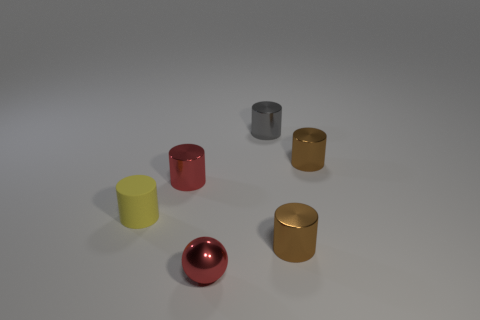Subtract all small yellow rubber cylinders. How many cylinders are left? 4 Subtract all gray cylinders. How many cylinders are left? 4 Subtract all cylinders. How many objects are left? 1 Subtract 1 spheres. How many spheres are left? 0 Subtract all gray balls. Subtract all yellow blocks. How many balls are left? 1 Subtract all green balls. How many gray cylinders are left? 1 Subtract all tiny red rubber cubes. Subtract all gray cylinders. How many objects are left? 5 Add 3 brown cylinders. How many brown cylinders are left? 5 Add 2 small shiny things. How many small shiny things exist? 7 Add 3 small brown metal spheres. How many objects exist? 9 